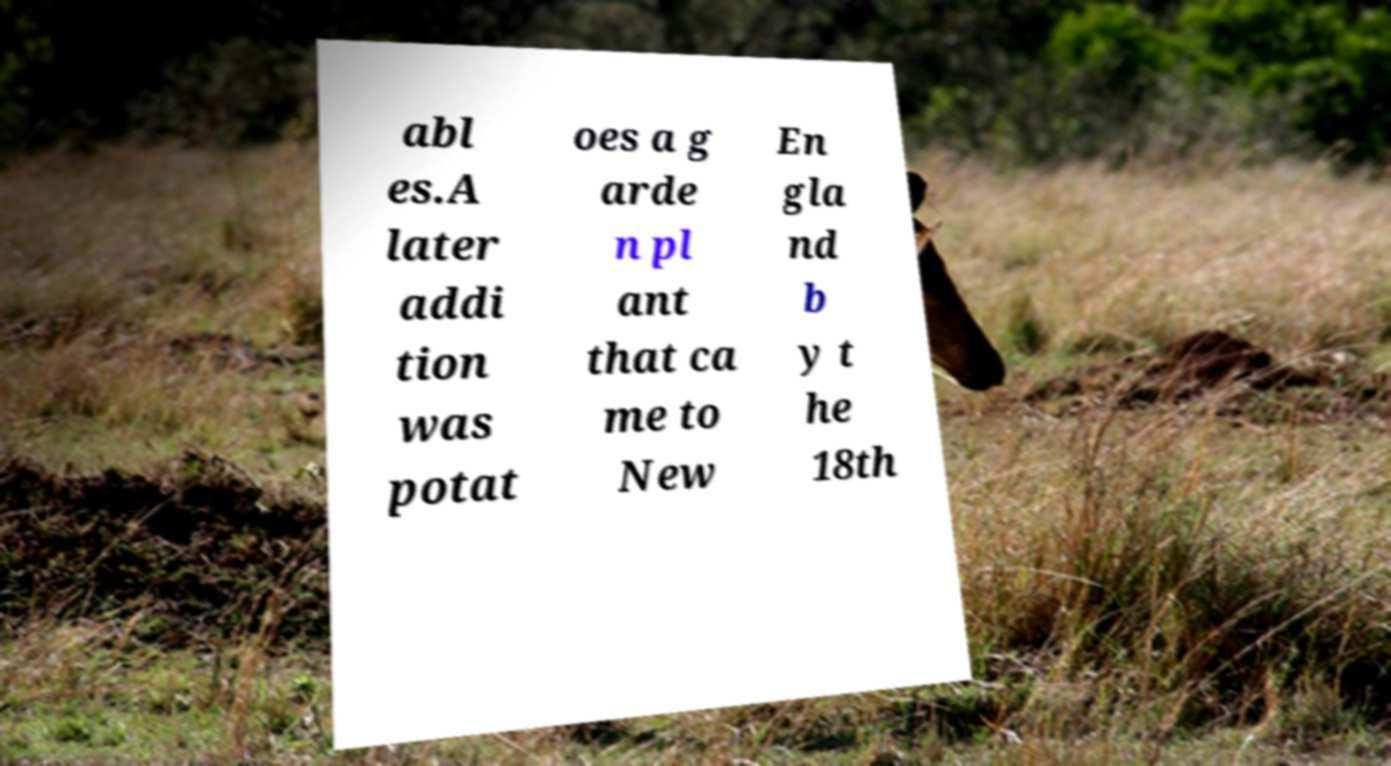Could you assist in decoding the text presented in this image and type it out clearly? abl es.A later addi tion was potat oes a g arde n pl ant that ca me to New En gla nd b y t he 18th 